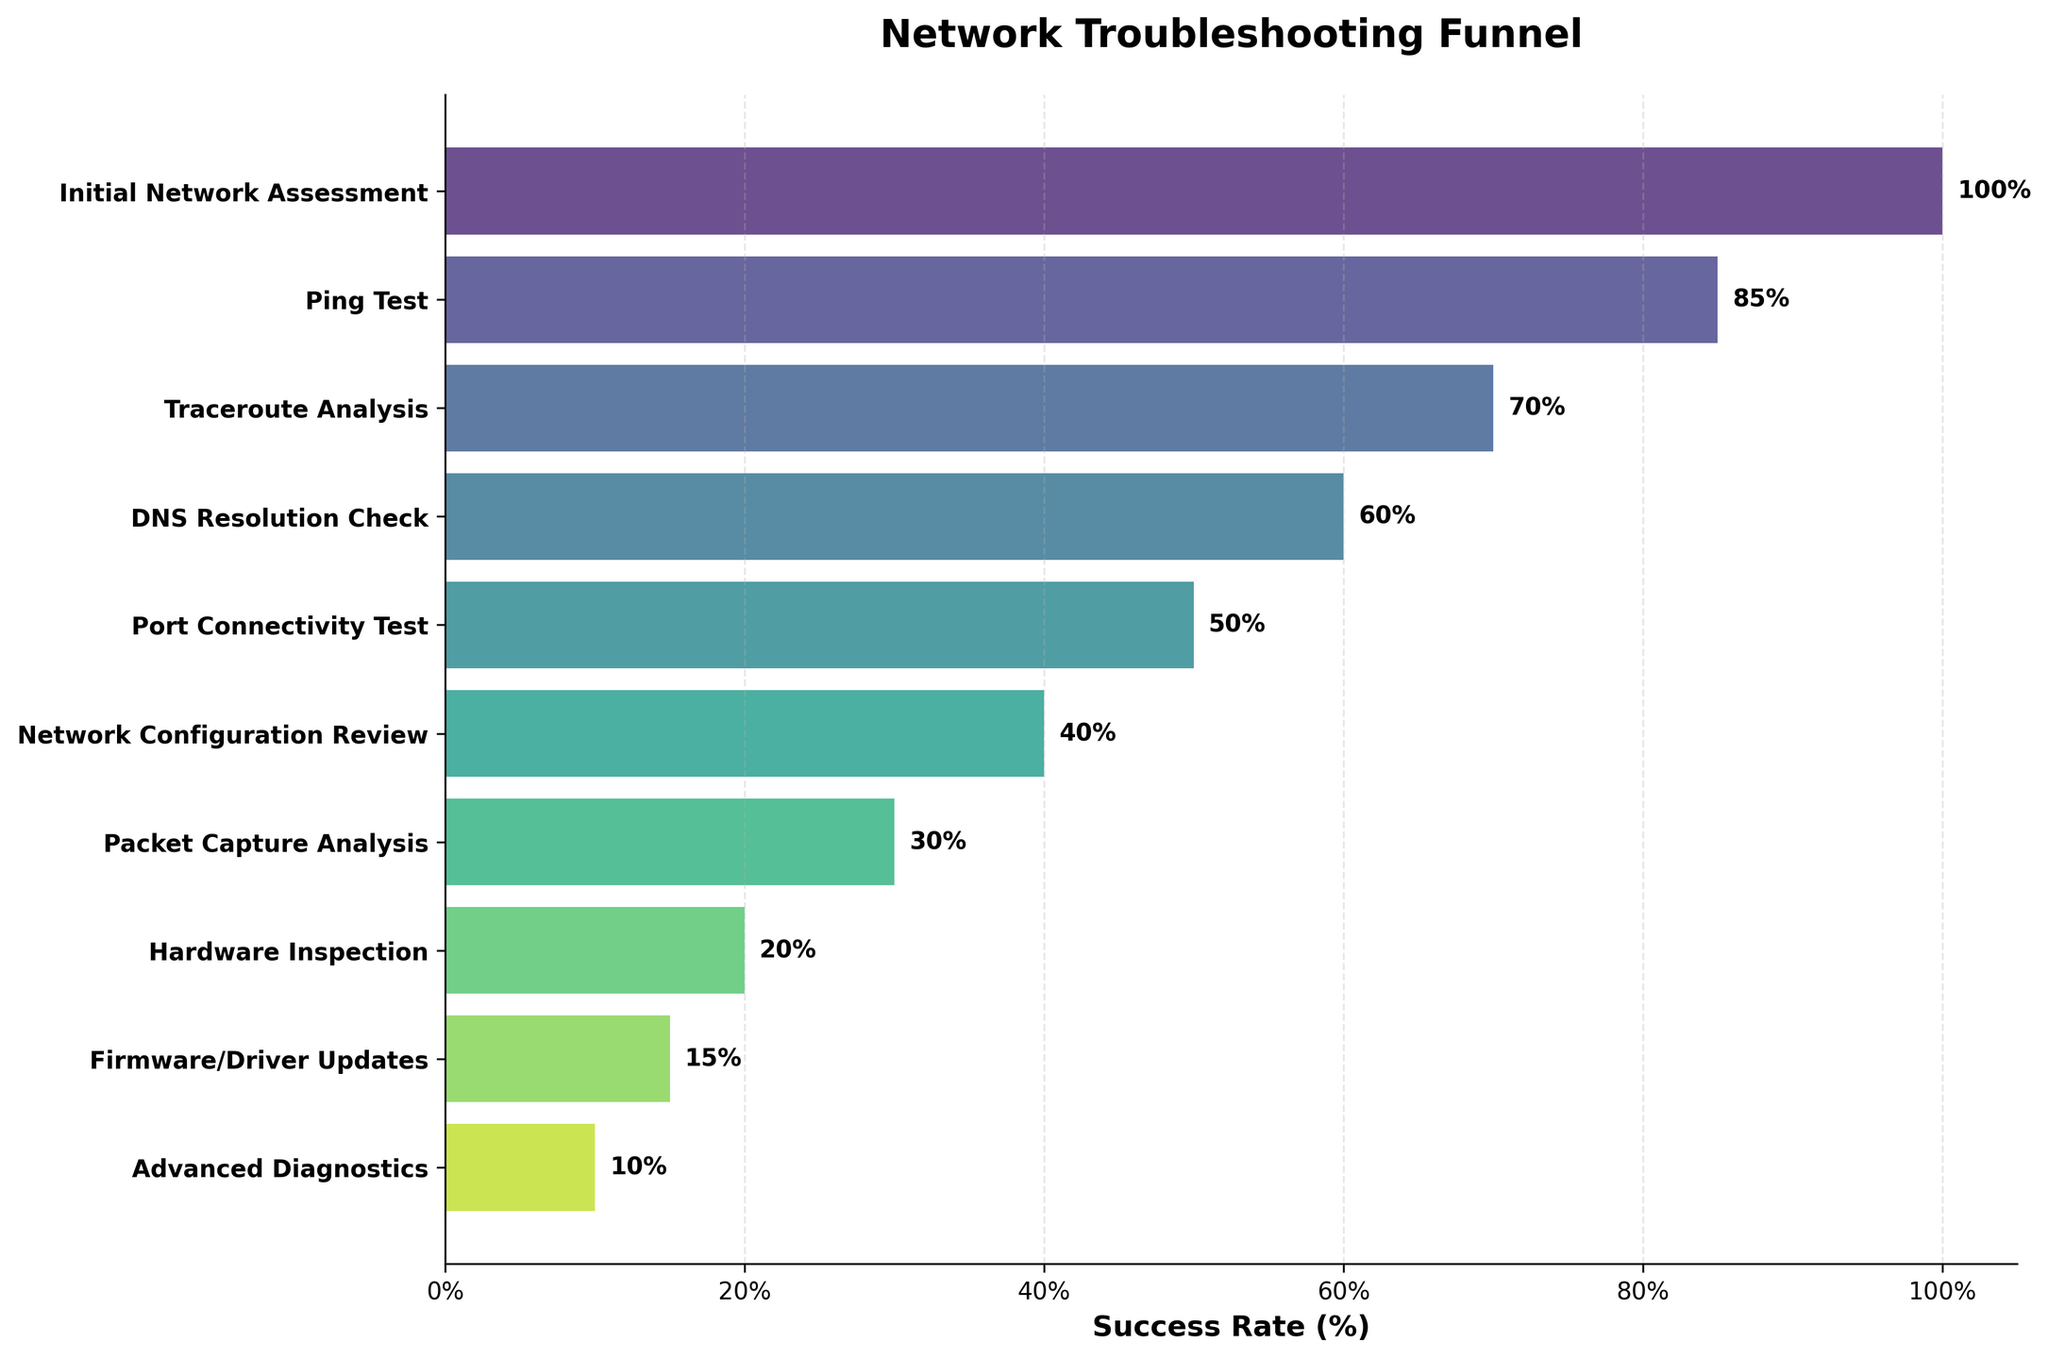What's the title of the figure? The title of the figure is located at the top of the plot. It summarizes the main subject of the visualization.
Answer: Network Troubleshooting Funnel What is the success rate for performing a Ping Test? The success rate for the Ping Test can be found on the y-axis, aligned with the corresponding bar, and also labeled at the end of the bar.
Answer: 85% How many stages are included in the funnel? Count the number of stages listed on the y-axis. Each stage name corresponds to a horizontal bar in the funnel chart.
Answer: 10 Which stage has the lowest success rate? Identify the shortest bar and refer to the y-axis label for that bar.
Answer: Advanced Diagnostics What is the difference in success rate between DNS Resolution Check and Hardware Inspection? Locate the bars for DNS Resolution Check and Hardware Inspection. Subtract the success rate of Hardware Inspection from that of DNS Resolution Check.
Answer: 40% What is the average success rate of all stages? Add all the success rates, then divide by the number of stages. Calculation: (100 + 85 + 70 + 60 + 50 + 40 + 30 + 20 + 15 + 10) / 10 = 48
Answer: 48% How does the success rate of Firmware/Driver Updates compare to Traceroute Analysis? Compare the length of the bars for both stages and check the success rate labels.
Answer: Firmware/Driver Updates (15%) is lower than Traceroute Analysis (70%) What stage shows a 40% success rate? Locate the bar with a 40% success rate label at the end, then refer to the y-axis label to find the stage name.
Answer: Network Configuration Review By how much does the success rate decrease from the Ping Test to the Packet Capture Analysis? Subtract the success rate of Packet Capture Analysis from that of the Ping Test. Calculation: 85 - 30 = 55
Answer: 55% What is the median success rate of the stages? List the success rates in ascending order and find the middle value. Since there are 10 values, calculate the average of the 5th and 6th values. Calculation: (50 + 40) / 2 = 45
Answer: 45 